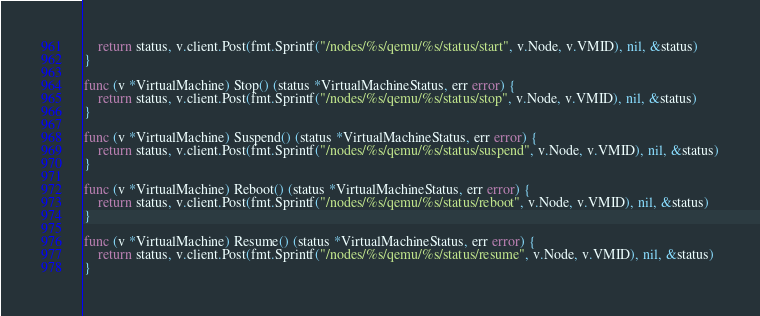<code> <loc_0><loc_0><loc_500><loc_500><_Go_>	return status, v.client.Post(fmt.Sprintf("/nodes/%s/qemu/%s/status/start", v.Node, v.VMID), nil, &status)
}

func (v *VirtualMachine) Stop() (status *VirtualMachineStatus, err error) {
	return status, v.client.Post(fmt.Sprintf("/nodes/%s/qemu/%s/status/stop", v.Node, v.VMID), nil, &status)
}

func (v *VirtualMachine) Suspend() (status *VirtualMachineStatus, err error) {
	return status, v.client.Post(fmt.Sprintf("/nodes/%s/qemu/%s/status/suspend", v.Node, v.VMID), nil, &status)
}

func (v *VirtualMachine) Reboot() (status *VirtualMachineStatus, err error) {
	return status, v.client.Post(fmt.Sprintf("/nodes/%s/qemu/%s/status/reboot", v.Node, v.VMID), nil, &status)
}

func (v *VirtualMachine) Resume() (status *VirtualMachineStatus, err error) {
	return status, v.client.Post(fmt.Sprintf("/nodes/%s/qemu/%s/status/resume", v.Node, v.VMID), nil, &status)
}
</code> 